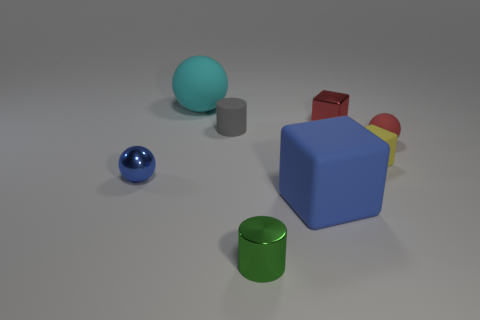How many other things are there of the same color as the shiny sphere?
Your answer should be compact. 1. There is a tiny ball that is the same color as the large rubber cube; what is its material?
Your response must be concise. Metal. Does the green object have the same material as the red block?
Provide a succinct answer. Yes. What number of metallic things are in front of the big rubber thing in front of the tiny shiny object behind the small matte cylinder?
Ensure brevity in your answer.  1. Is there a tiny gray thing made of the same material as the large cyan object?
Provide a short and direct response. Yes. There is a shiny object that is the same color as the large rubber cube; what size is it?
Provide a succinct answer. Small. Is the number of blue metallic cubes less than the number of yellow blocks?
Make the answer very short. Yes. Does the small cylinder that is in front of the tiny gray matte object have the same color as the big matte block?
Give a very brief answer. No. What is the small cube in front of the cylinder that is behind the matte block to the left of the red cube made of?
Your response must be concise. Rubber. Is there a shiny cylinder that has the same color as the small matte cylinder?
Your answer should be very brief. No. 